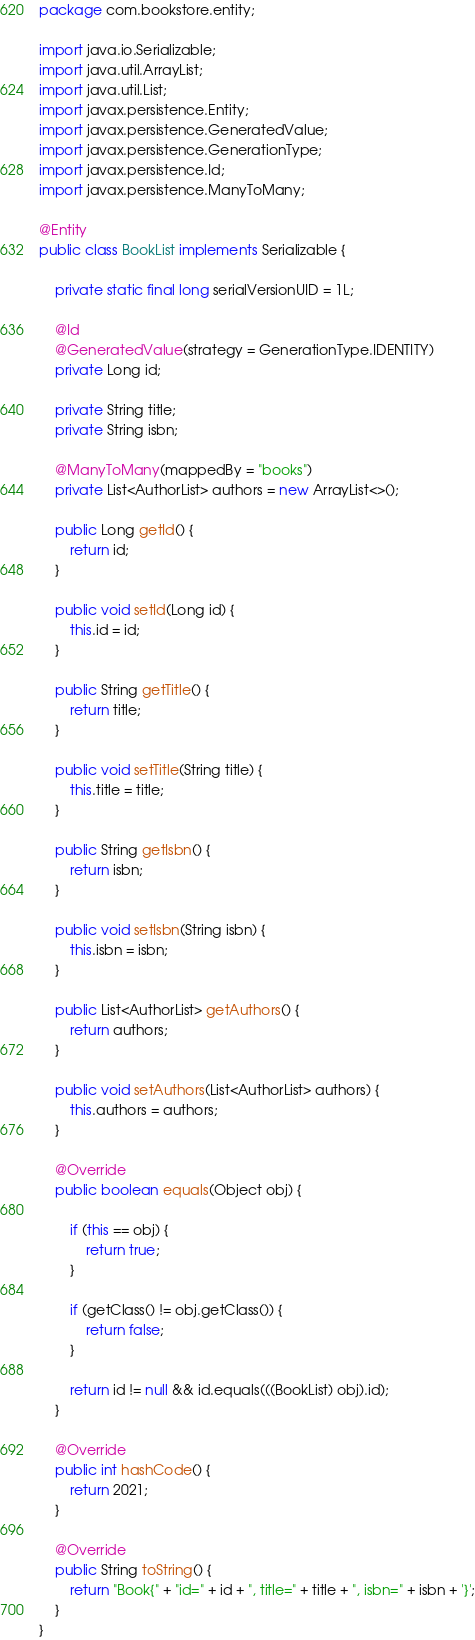Convert code to text. <code><loc_0><loc_0><loc_500><loc_500><_Java_>package com.bookstore.entity;

import java.io.Serializable;
import java.util.ArrayList;
import java.util.List;
import javax.persistence.Entity;
import javax.persistence.GeneratedValue;
import javax.persistence.GenerationType;
import javax.persistence.Id;
import javax.persistence.ManyToMany;

@Entity
public class BookList implements Serializable {

    private static final long serialVersionUID = 1L;

    @Id
    @GeneratedValue(strategy = GenerationType.IDENTITY)
    private Long id;

    private String title;
    private String isbn;

    @ManyToMany(mappedBy = "books")
    private List<AuthorList> authors = new ArrayList<>();

    public Long getId() {
        return id;
    }

    public void setId(Long id) {
        this.id = id;
    }

    public String getTitle() {
        return title;
    }

    public void setTitle(String title) {
        this.title = title;
    }

    public String getIsbn() {
        return isbn;
    }

    public void setIsbn(String isbn) {
        this.isbn = isbn;
    }

    public List<AuthorList> getAuthors() {
        return authors;
    }

    public void setAuthors(List<AuthorList> authors) {
        this.authors = authors;
    }

    @Override
    public boolean equals(Object obj) {

        if (this == obj) {
            return true;
        }

        if (getClass() != obj.getClass()) {
            return false;
        }

        return id != null && id.equals(((BookList) obj).id);
    }

    @Override
    public int hashCode() {
        return 2021;
    }

    @Override
    public String toString() {
        return "Book{" + "id=" + id + ", title=" + title + ", isbn=" + isbn + '}';
    }
}
</code> 